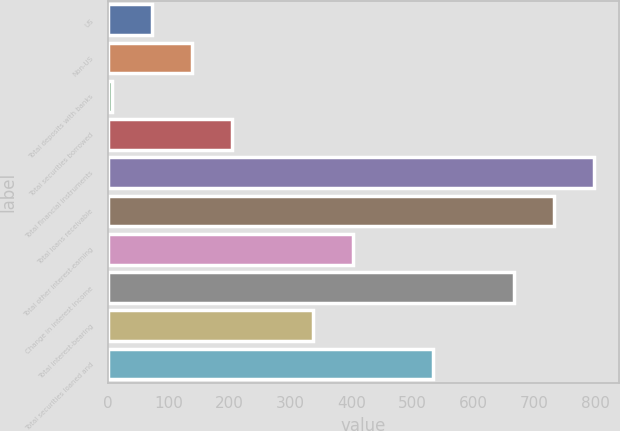Convert chart. <chart><loc_0><loc_0><loc_500><loc_500><bar_chart><fcel>US<fcel>Non-US<fcel>Total deposits with banks<fcel>Total securities borrowed<fcel>Total financial instruments<fcel>Total loans receivable<fcel>Total other interest-earning<fcel>Change in interest income<fcel>Total interest-bearing<fcel>Total securities loaned and<nl><fcel>72.9<fcel>138.8<fcel>7<fcel>204.7<fcel>797.8<fcel>731.9<fcel>402.4<fcel>666<fcel>336.5<fcel>534.2<nl></chart> 